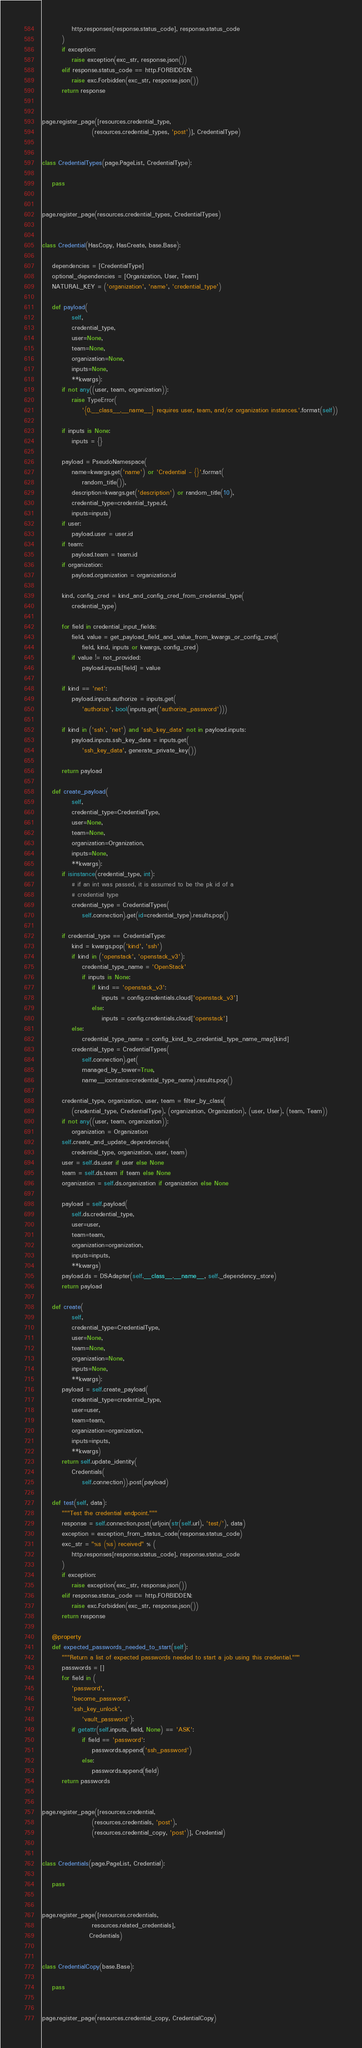Convert code to text. <code><loc_0><loc_0><loc_500><loc_500><_Python_>            http.responses[response.status_code], response.status_code
        )
        if exception:
            raise exception(exc_str, response.json())
        elif response.status_code == http.FORBIDDEN:
            raise exc.Forbidden(exc_str, response.json())
        return response


page.register_page([resources.credential_type,
                    (resources.credential_types, 'post')], CredentialType)


class CredentialTypes(page.PageList, CredentialType):

    pass


page.register_page(resources.credential_types, CredentialTypes)


class Credential(HasCopy, HasCreate, base.Base):

    dependencies = [CredentialType]
    optional_dependencies = [Organization, User, Team]
    NATURAL_KEY = ('organization', 'name', 'credential_type')

    def payload(
            self,
            credential_type,
            user=None,
            team=None,
            organization=None,
            inputs=None,
            **kwargs):
        if not any((user, team, organization)):
            raise TypeError(
                '{0.__class__.__name__} requires user, team, and/or organization instances.'.format(self))

        if inputs is None:
            inputs = {}

        payload = PseudoNamespace(
            name=kwargs.get('name') or 'Credential - {}'.format(
                random_title()),
            description=kwargs.get('description') or random_title(10),
            credential_type=credential_type.id,
            inputs=inputs)
        if user:
            payload.user = user.id
        if team:
            payload.team = team.id
        if organization:
            payload.organization = organization.id

        kind, config_cred = kind_and_config_cred_from_credential_type(
            credential_type)

        for field in credential_input_fields:
            field, value = get_payload_field_and_value_from_kwargs_or_config_cred(
                field, kind, inputs or kwargs, config_cred)
            if value != not_provided:
                payload.inputs[field] = value

        if kind == 'net':
            payload.inputs.authorize = inputs.get(
                'authorize', bool(inputs.get('authorize_password')))

        if kind in ('ssh', 'net') and 'ssh_key_data' not in payload.inputs:
            payload.inputs.ssh_key_data = inputs.get(
                'ssh_key_data', generate_private_key())

        return payload

    def create_payload(
            self,
            credential_type=CredentialType,
            user=None,
            team=None,
            organization=Organization,
            inputs=None,
            **kwargs):
        if isinstance(credential_type, int):
            # if an int was passed, it is assumed to be the pk id of a
            # credential type
            credential_type = CredentialTypes(
                self.connection).get(id=credential_type).results.pop()

        if credential_type == CredentialType:
            kind = kwargs.pop('kind', 'ssh')
            if kind in ('openstack', 'openstack_v3'):
                credential_type_name = 'OpenStack'
                if inputs is None:
                    if kind == 'openstack_v3':
                        inputs = config.credentials.cloud['openstack_v3']
                    else:
                        inputs = config.credentials.cloud['openstack']
            else:
                credential_type_name = config_kind_to_credential_type_name_map[kind]
            credential_type = CredentialTypes(
                self.connection).get(
                managed_by_tower=True,
                name__icontains=credential_type_name).results.pop()

        credential_type, organization, user, team = filter_by_class(
            (credential_type, CredentialType), (organization, Organization), (user, User), (team, Team))
        if not any((user, team, organization)):
            organization = Organization
        self.create_and_update_dependencies(
            credential_type, organization, user, team)
        user = self.ds.user if user else None
        team = self.ds.team if team else None
        organization = self.ds.organization if organization else None

        payload = self.payload(
            self.ds.credential_type,
            user=user,
            team=team,
            organization=organization,
            inputs=inputs,
            **kwargs)
        payload.ds = DSAdapter(self.__class__.__name__, self._dependency_store)
        return payload

    def create(
            self,
            credential_type=CredentialType,
            user=None,
            team=None,
            organization=None,
            inputs=None,
            **kwargs):
        payload = self.create_payload(
            credential_type=credential_type,
            user=user,
            team=team,
            organization=organization,
            inputs=inputs,
            **kwargs)
        return self.update_identity(
            Credentials(
                self.connection)).post(payload)

    def test(self, data):
        """Test the credential endpoint."""
        response = self.connection.post(urljoin(str(self.url), 'test/'), data)
        exception = exception_from_status_code(response.status_code)
        exc_str = "%s (%s) received" % (
            http.responses[response.status_code], response.status_code
        )
        if exception:
            raise exception(exc_str, response.json())
        elif response.status_code == http.FORBIDDEN:
            raise exc.Forbidden(exc_str, response.json())
        return response

    @property
    def expected_passwords_needed_to_start(self):
        """Return a list of expected passwords needed to start a job using this credential."""
        passwords = []
        for field in (
            'password',
            'become_password',
            'ssh_key_unlock',
                'vault_password'):
            if getattr(self.inputs, field, None) == 'ASK':
                if field == 'password':
                    passwords.append('ssh_password')
                else:
                    passwords.append(field)
        return passwords


page.register_page([resources.credential,
                    (resources.credentials, 'post'),
                    (resources.credential_copy, 'post')], Credential)


class Credentials(page.PageList, Credential):

    pass


page.register_page([resources.credentials,
                    resources.related_credentials],
                   Credentials)


class CredentialCopy(base.Base):

    pass


page.register_page(resources.credential_copy, CredentialCopy)
</code> 